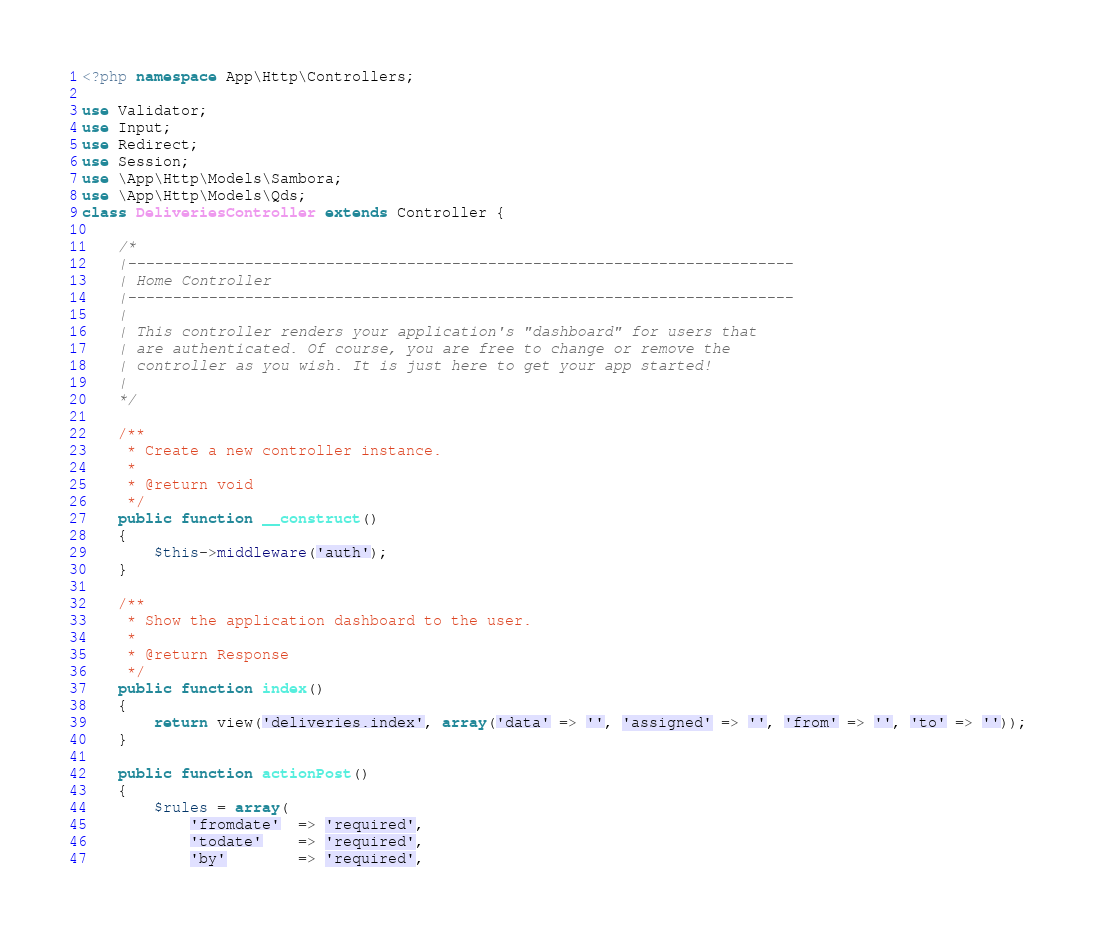<code> <loc_0><loc_0><loc_500><loc_500><_PHP_><?php namespace App\Http\Controllers;

use Validator;
use Input;
use Redirect;
use Session;
use \App\Http\Models\Sambora;
use \App\Http\Models\Qds;
class DeliveriesController extends Controller {

	/*
	|--------------------------------------------------------------------------
	| Home Controller
	|--------------------------------------------------------------------------
	|
	| This controller renders your application's "dashboard" for users that
	| are authenticated. Of course, you are free to change or remove the
	| controller as you wish. It is just here to get your app started!
	|
	*/

	/**
	 * Create a new controller instance.
	 *
	 * @return void
	 */
	public function __construct()
	{
		$this->middleware('auth');
	}

	/**
	 * Show the application dashboard to the user.
	 *
	 * @return Response
	 */
	public function index()
	{
		return view('deliveries.index', array('data' => '', 'assigned' => '', 'from' => '', 'to' => ''));
	}

	public function actionPost()
	{
		$rules = array(
            'fromdate'  => 'required',
            'todate'    => 'required',
            'by'    	=> 'required',</code> 